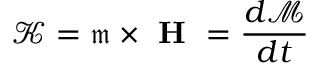Convert formula to latex. <formula><loc_0><loc_0><loc_500><loc_500>\mathcal { K } = \mathfrak { m } \times H = \frac { d \mathcal { M } } { d t }</formula> 